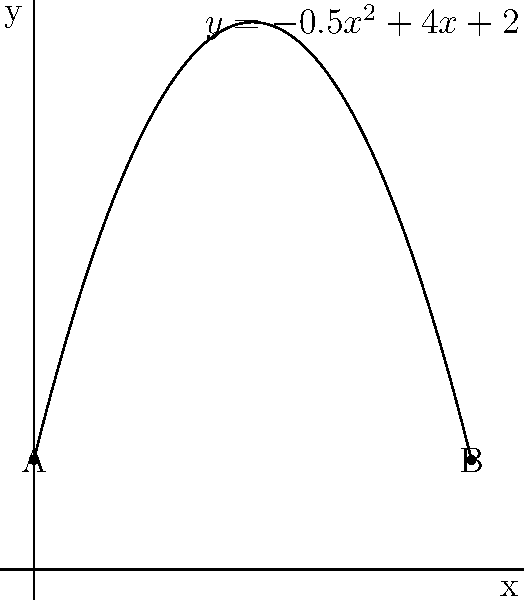In your game, resource distribution across a map is modeled by the polynomial function $f(x) = -0.5x^2 + 4x + 2$, where $x$ represents the distance from the starting point (in km) and $f(x)$ represents the resource density. The map extends from point A (0 km) to point B (8 km). At what distance from the starting point is the resource density maximized, and what is the maximum density? To find the maximum resource density, we need to follow these steps:

1) The maximum of a quadratic function occurs at the vertex of the parabola. For a quadratic function in the form $f(x) = ax^2 + bx + c$, the x-coordinate of the vertex is given by $x = -\frac{b}{2a}$.

2) In our function $f(x) = -0.5x^2 + 4x + 2$, we have:
   $a = -0.5$
   $b = 4$
   $c = 2$

3) Plugging into the vertex formula:
   $x = -\frac{4}{2(-0.5)} = -\frac{4}{-1} = 4$

4) So the maximum occurs at $x = 4$ km from the starting point.

5) To find the maximum density, we evaluate $f(4)$:
   $f(4) = -0.5(4)^2 + 4(4) + 2$
         $= -0.5(16) + 16 + 2$
         $= -8 + 16 + 2$
         $= 10$

Therefore, the resource density is maximized at 4 km from the starting point, with a maximum density of 10 units.
Answer: 4 km from start; maximum density of 10 units 